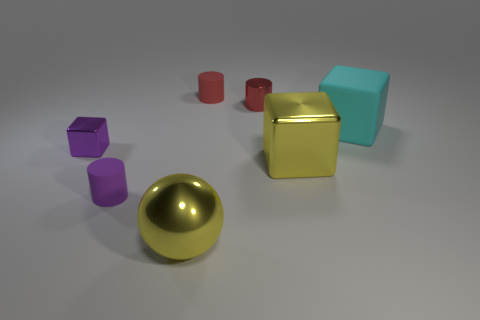There is a cylinder right of the tiny red matte object; is its size the same as the cube behind the tiny metal block?
Offer a very short reply. No. There is a cyan object; are there any matte objects to the left of it?
Your answer should be very brief. Yes. What color is the small cylinder in front of the small cube to the left of the cyan block?
Give a very brief answer. Purple. Is the number of matte cylinders less than the number of cubes?
Your response must be concise. Yes. What number of cyan objects are the same shape as the purple matte thing?
Provide a succinct answer. 0. There is a metal cube that is the same size as the yellow sphere; what is its color?
Provide a short and direct response. Yellow. Are there the same number of purple blocks on the right side of the cyan cube and large yellow shiny things that are on the left side of the small purple shiny cube?
Provide a succinct answer. Yes. Are there any purple matte cylinders that have the same size as the red matte cylinder?
Provide a short and direct response. Yes. The rubber cube is what size?
Offer a very short reply. Large. Are there an equal number of large yellow shiny blocks left of the small metal cube and small cyan rubber cubes?
Offer a terse response. Yes. 